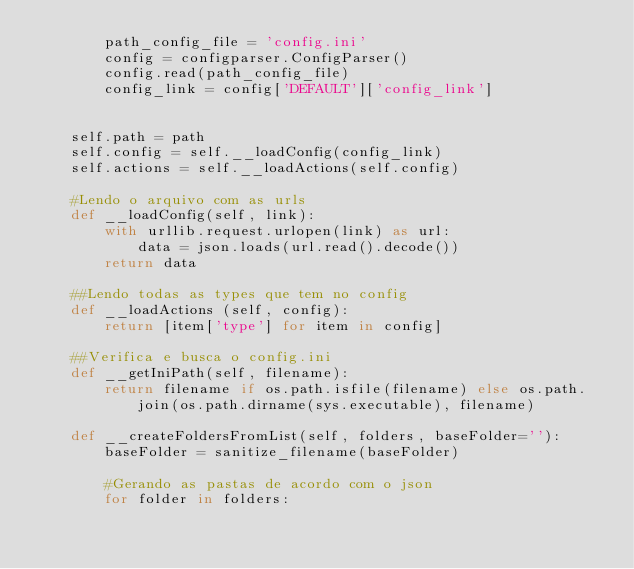<code> <loc_0><loc_0><loc_500><loc_500><_Python_>        path_config_file = 'config.ini'
        config = configparser.ConfigParser()
        config.read(path_config_file)
        config_link = config['DEFAULT']['config_link']


    self.path = path
    self.config = self.__loadConfig(config_link)
    self.actions = self.__loadActions(self.config)

    #Lendo o arquivo com as urls 
    def __loadConfig(self, link):
        with urllib.request.urlopen(link) as url:
            data = json.loads(url.read().decode())
        return data

    ##Lendo todas as types que tem no config
    def __loadActions (self, config):
        return [item['type'] for item in config]

    ##Verifica e busca o config.ini
    def __getIniPath(self, filename):
        return filename if os.path.isfile(filename) else os.path.join(os.path.dirname(sys.executable), filename)

    def __createFoldersFromList(self, folders, baseFolder=''):
        baseFolder = sanitize_filename(baseFolder)

        #Gerando as pastas de acordo com o json
        for folder in folders:</code> 